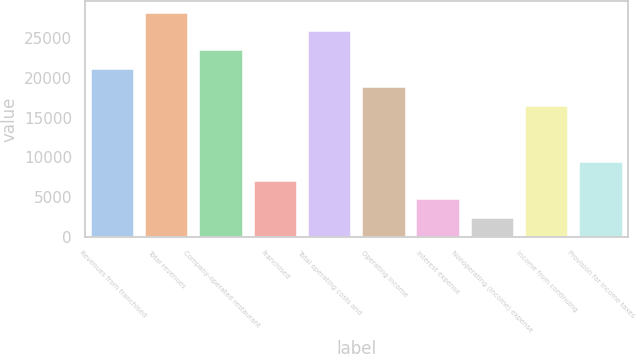<chart> <loc_0><loc_0><loc_500><loc_500><bar_chart><fcel>Revenues from franchised<fcel>Total revenues<fcel>Company-operated restaurant<fcel>Franchised<fcel>Total operating costs and<fcel>Operating income<fcel>Interest expense<fcel>Nonoperating (income) expense<fcel>Income from continuing<fcel>Provision for income taxes<nl><fcel>21170.1<fcel>28225.6<fcel>23522<fcel>7059.22<fcel>25873.8<fcel>18818.3<fcel>4707.4<fcel>2355.58<fcel>16466.5<fcel>9411.04<nl></chart> 